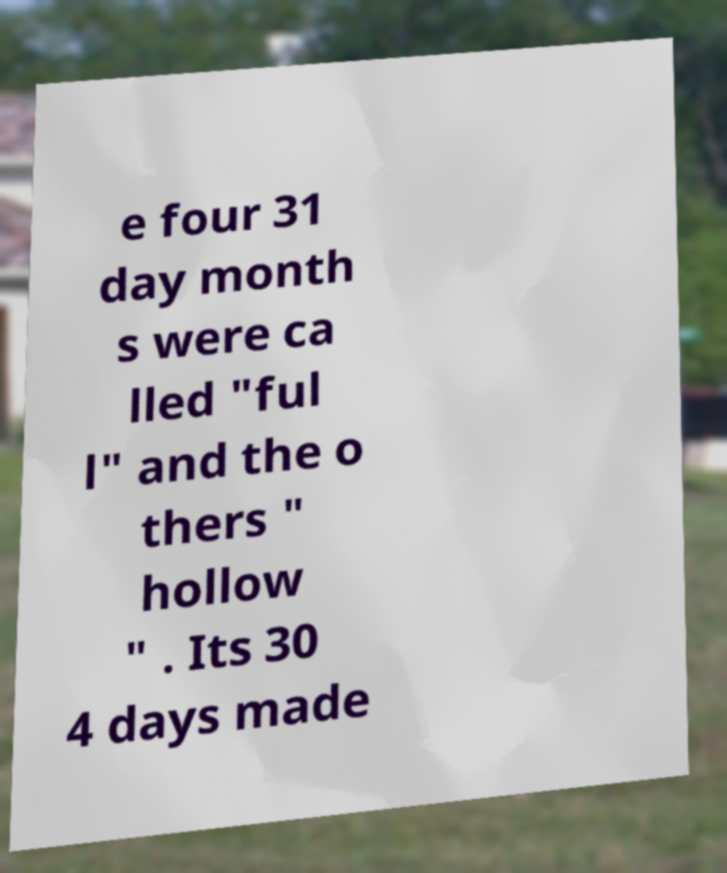Can you read and provide the text displayed in the image?This photo seems to have some interesting text. Can you extract and type it out for me? e four 31 day month s were ca lled "ful l" and the o thers " hollow " . Its 30 4 days made 